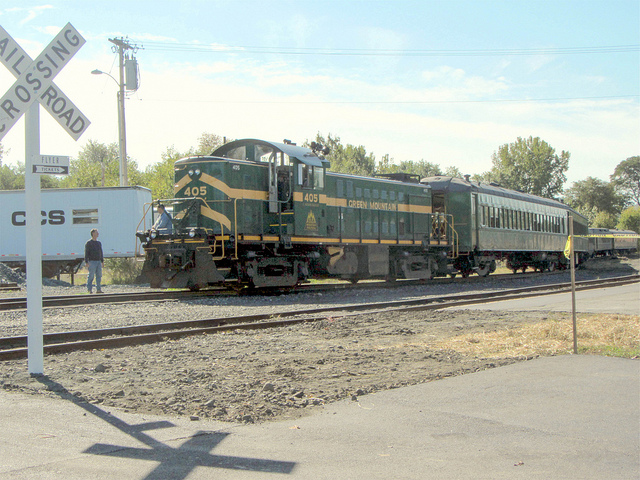Identify the text displayed in this image. ROAD ROAD 405 405 GREEN CS AIL 